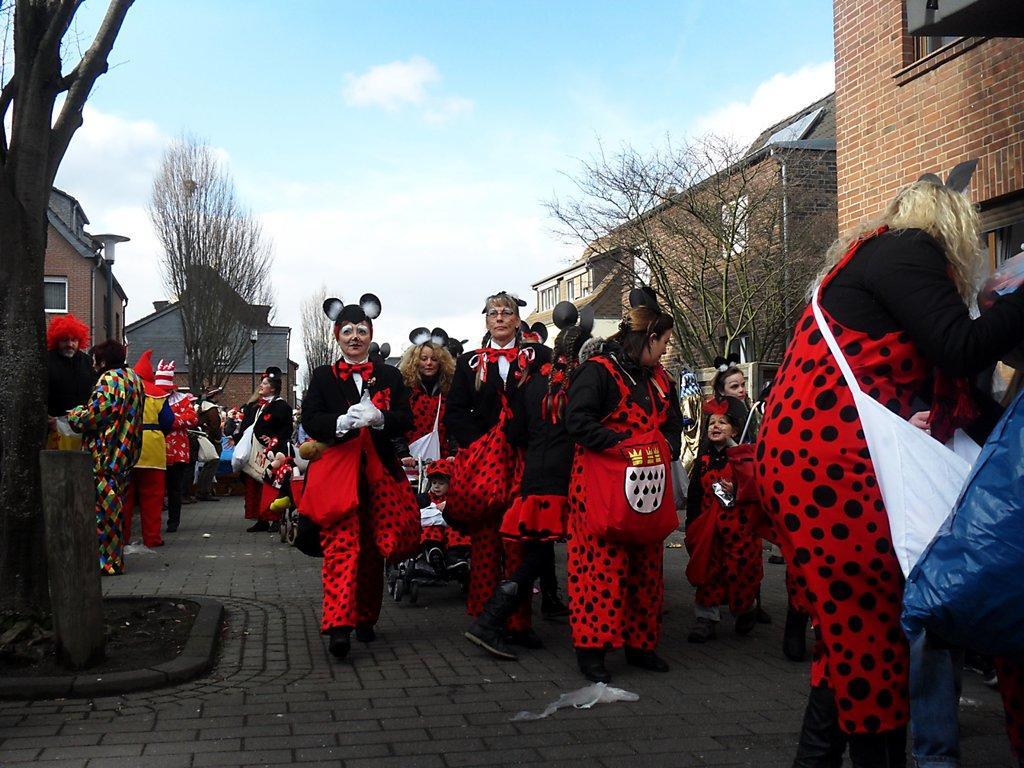How would you summarize this image in a sentence or two? In the center of the image there are people wearing costumes. In the background there are trees, buildings and sky. 